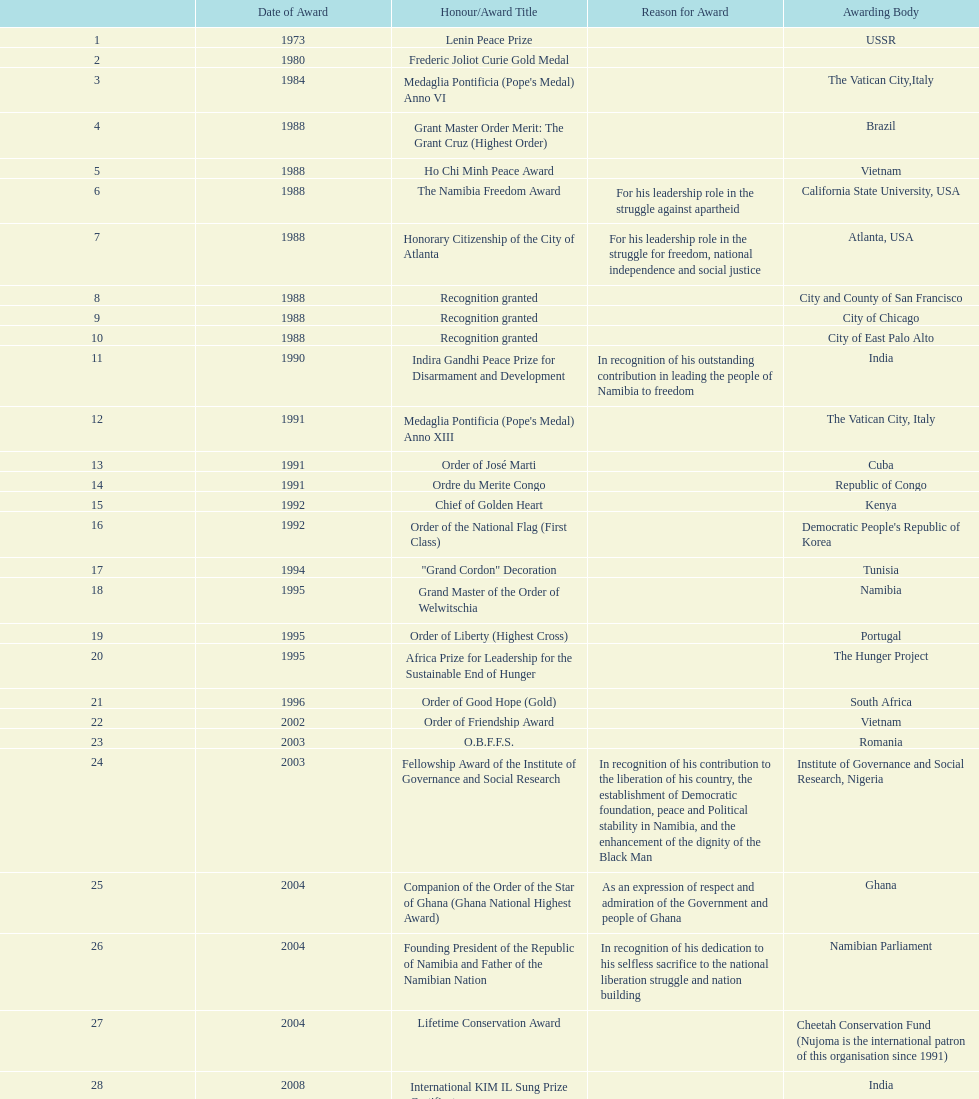What is the latest award that nujoma has been given? Sir Seretse Khama SADC Meda. 